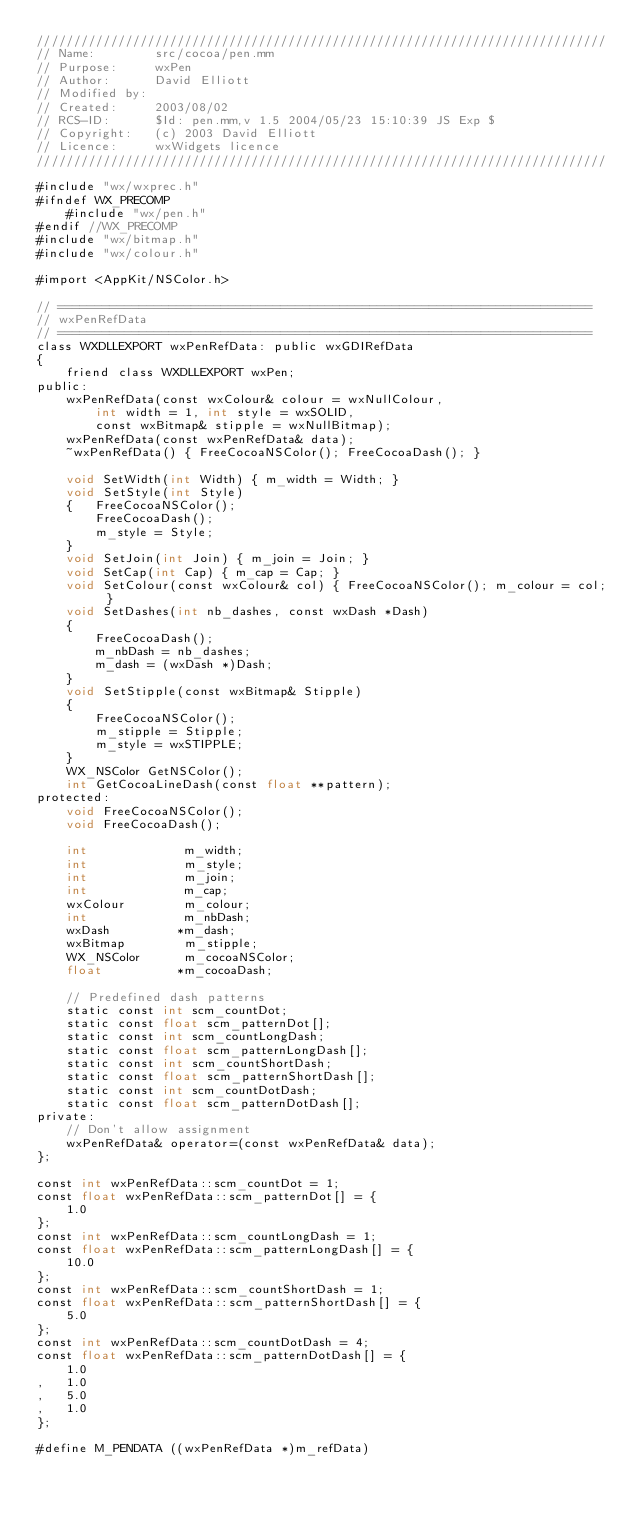Convert code to text. <code><loc_0><loc_0><loc_500><loc_500><_ObjectiveC_>/////////////////////////////////////////////////////////////////////////////
// Name:        src/cocoa/pen.mm
// Purpose:     wxPen
// Author:      David Elliott
// Modified by:
// Created:     2003/08/02
// RCS-ID:      $Id: pen.mm,v 1.5 2004/05/23 15:10:39 JS Exp $
// Copyright:   (c) 2003 David Elliott
// Licence:   	wxWidgets licence
/////////////////////////////////////////////////////////////////////////////

#include "wx/wxprec.h"
#ifndef WX_PRECOMP
    #include "wx/pen.h"
#endif //WX_PRECOMP
#include "wx/bitmap.h"
#include "wx/colour.h"

#import <AppKit/NSColor.h>

// ========================================================================
// wxPenRefData
// ========================================================================
class WXDLLEXPORT wxPenRefData: public wxGDIRefData
{
    friend class WXDLLEXPORT wxPen;
public:
    wxPenRefData(const wxColour& colour = wxNullColour,
        int width = 1, int style = wxSOLID,
        const wxBitmap& stipple = wxNullBitmap);
    wxPenRefData(const wxPenRefData& data);
    ~wxPenRefData() { FreeCocoaNSColor(); FreeCocoaDash(); }

    void SetWidth(int Width) { m_width = Width; }
    void SetStyle(int Style)
    {   FreeCocoaNSColor();
        FreeCocoaDash();
        m_style = Style;
    }
    void SetJoin(int Join) { m_join = Join; }
    void SetCap(int Cap) { m_cap = Cap; }
    void SetColour(const wxColour& col) { FreeCocoaNSColor(); m_colour = col; }
    void SetDashes(int nb_dashes, const wxDash *Dash)
    {
        FreeCocoaDash();
        m_nbDash = nb_dashes;
        m_dash = (wxDash *)Dash;
    }
    void SetStipple(const wxBitmap& Stipple)
    {
        FreeCocoaNSColor();
        m_stipple = Stipple;
        m_style = wxSTIPPLE;
    }
    WX_NSColor GetNSColor();
    int GetCocoaLineDash(const float **pattern);
protected:
    void FreeCocoaNSColor();
    void FreeCocoaDash();

    int             m_width;
    int             m_style;
    int             m_join;
    int             m_cap;
    wxColour        m_colour;
    int             m_nbDash;
    wxDash         *m_dash;
    wxBitmap        m_stipple;
    WX_NSColor      m_cocoaNSColor;
    float          *m_cocoaDash;

    // Predefined dash patterns
    static const int scm_countDot;
    static const float scm_patternDot[];
    static const int scm_countLongDash;
    static const float scm_patternLongDash[];
    static const int scm_countShortDash;
    static const float scm_patternShortDash[];
    static const int scm_countDotDash;
    static const float scm_patternDotDash[];
private:
    // Don't allow assignment
    wxPenRefData& operator=(const wxPenRefData& data);
};

const int wxPenRefData::scm_countDot = 1;
const float wxPenRefData::scm_patternDot[] = {
    1.0
};
const int wxPenRefData::scm_countLongDash = 1;
const float wxPenRefData::scm_patternLongDash[] = {
    10.0
};
const int wxPenRefData::scm_countShortDash = 1;
const float wxPenRefData::scm_patternShortDash[] = {
    5.0
};
const int wxPenRefData::scm_countDotDash = 4;
const float wxPenRefData::scm_patternDotDash[] = {
    1.0
,   1.0
,   5.0
,   1.0
};

#define M_PENDATA ((wxPenRefData *)m_refData)
</code> 